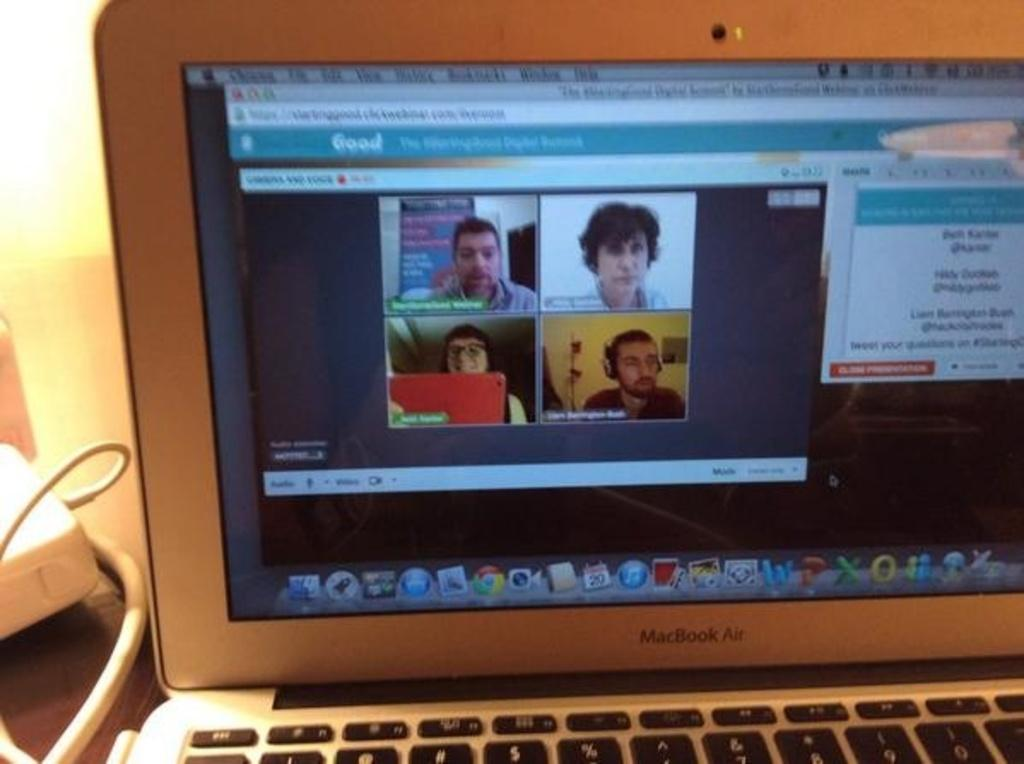What electronic device is visible in the image? There is a laptop in the image. Where is the laptop located? The laptop is on a table. What is displayed on the laptop screen? The laptop screen displays pictures and text. How is the laptop being powered in the image? There is a charger connected to the laptop on the left side. What type of bell can be heard ringing in the image? There is no bell present in the image, and therefore no sound can be heard. 